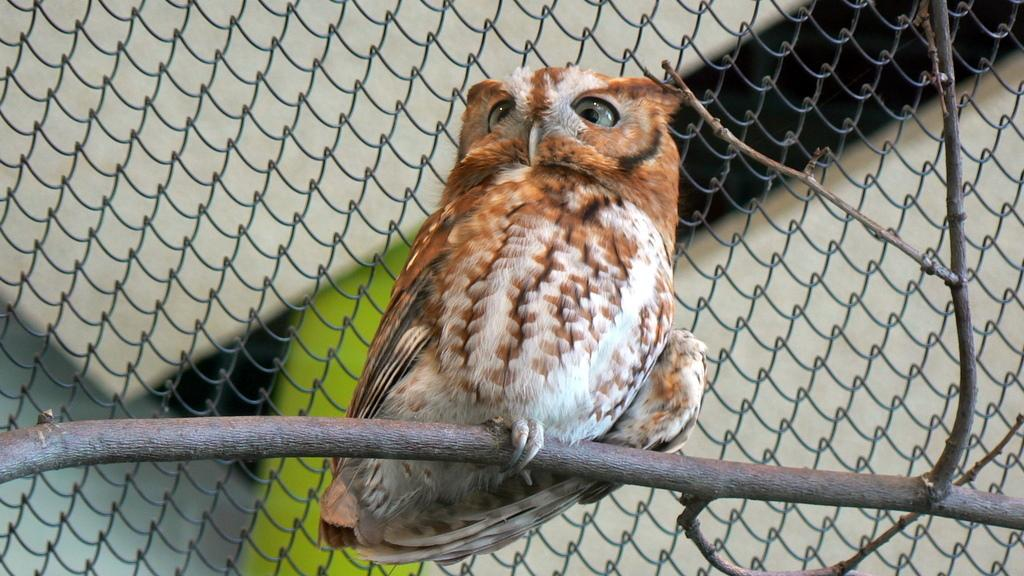What animal is featured in the image? There is an owl in the image. How is the owl positioned in the image? The owl is on a stick. What can be seen in the background of the image? There is a mesh in the background of the image. What type of feast is being prepared in the image? There is no indication of a feast being prepared in the image; it features an owl on a stick with a mesh background. 